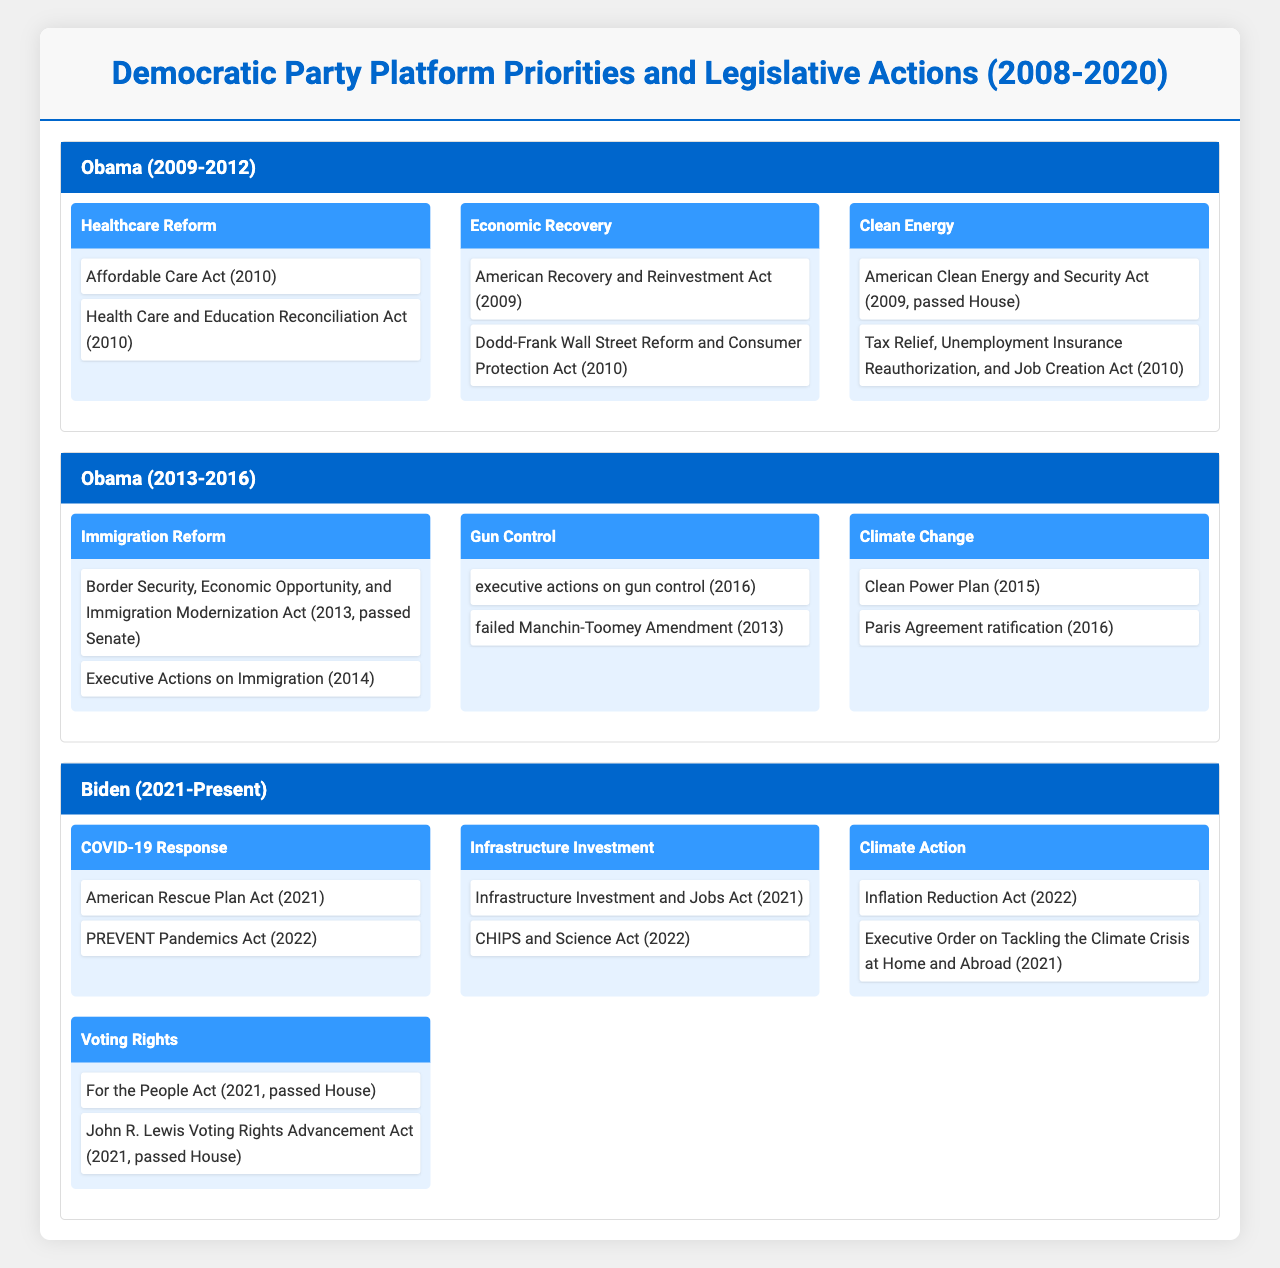What healthcare reform legislation was passed during Obama's first term? The table indicates that the Affordable Care Act and the Health Care and Education Reconciliation Act were both legislative actions under the priority of Healthcare Reform during Obama's first term.
Answer: Affordable Care Act and Health Care and Education Reconciliation Act Which presidential term had a focus on gun control? Gun control was a priority during Obama's second term, evidenced by two legislative actions: the executive actions on gun control in 2016 and the failed Manchin-Toomey Amendment in 2013.
Answer: Obama's second term What was the total number of legislative actions listed for Biden's administration? Biden's administration had four platform priorities, each with multiple legislative actions: COVID-19 Response (2), Infrastructure Investment (2), Climate Action (2), and Voting Rights (2). Thus, the total number is 2 + 2 + 2 + 2 = 8.
Answer: 8 Did the Democratic party address climate change in all presidential terms listed? Yes, the table shows that Climate Change was a priority during Obama's second term and Climate Action was a priority during Biden's term, indicating it was addressed in both terms, though it was not explicitly mentioned during Obama's first term.
Answer: Yes Which presidential term had the most unique platform priorities? In the table, Obama's first term had three unique platform priorities, while his second term had three as well, and Biden's term had four. Thus, Biden's term had the most unique platform priorities.
Answer: Biden's term What is the difference in the number of legislative actions dedicated to economic recovery between Obama's first and second terms? During Obama's first term, there were two legislative actions related to economic recovery, as listed under that priority, while his second term had no such priority. The difference is thus 2 - 0 = 2.
Answer: 2 True or False: The Inflation Reduction Act was a legislative action during Obama's presidency. The table shows that the Inflation Reduction Act is listed under Biden's term, not Obama's, indicating that the statement is false.
Answer: False What was the last legislative action taken under the priority of Voting Rights? The John R. Lewis Voting Rights Advancement Act was the last legislative action listed for the Voting Rights priority during Biden's term, specifically noted as being passed in the House in 2021.
Answer: John R. Lewis Voting Rights Advancement Act Which president had a legislative action related to immigration reform that passed the Senate? The Border Security, Economic Opportunity, and Immigration Modernization Act (2013) was listed as passing the Senate during Obama's second term, indicating that he was the president associated with this legislative action.
Answer: Obama How many platform priorities were focused on climate change across all three presidential terms? The table shows that climate change was a focus during Obama's second term (Climate Change) and also during Biden's term (Climate Action), giving a total of two distinct priorities focused on climate change across the terms.
Answer: 2 